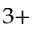Convert formula to latex. <formula><loc_0><loc_0><loc_500><loc_500>^ { 3 + }</formula> 